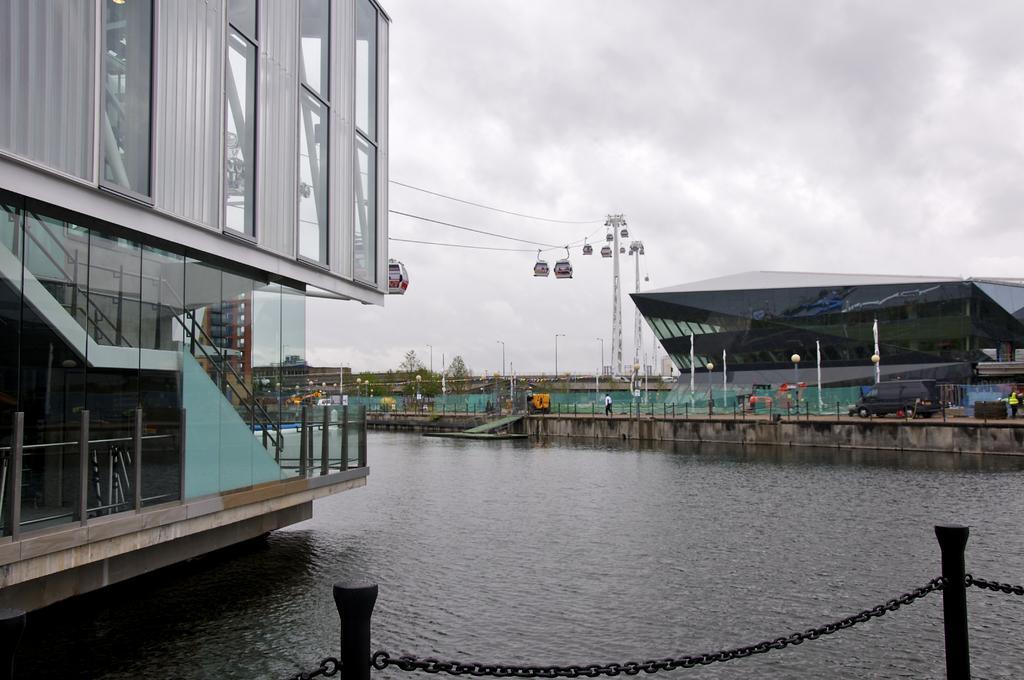Could you give a brief overview of what you see in this image? In this image we can see some buildings, grills, windows, there is a chain, rods, fencing, also we can see vehicle, and few people on the road, there is a sign board, plants, trees, and also we can see the river and the sky. 